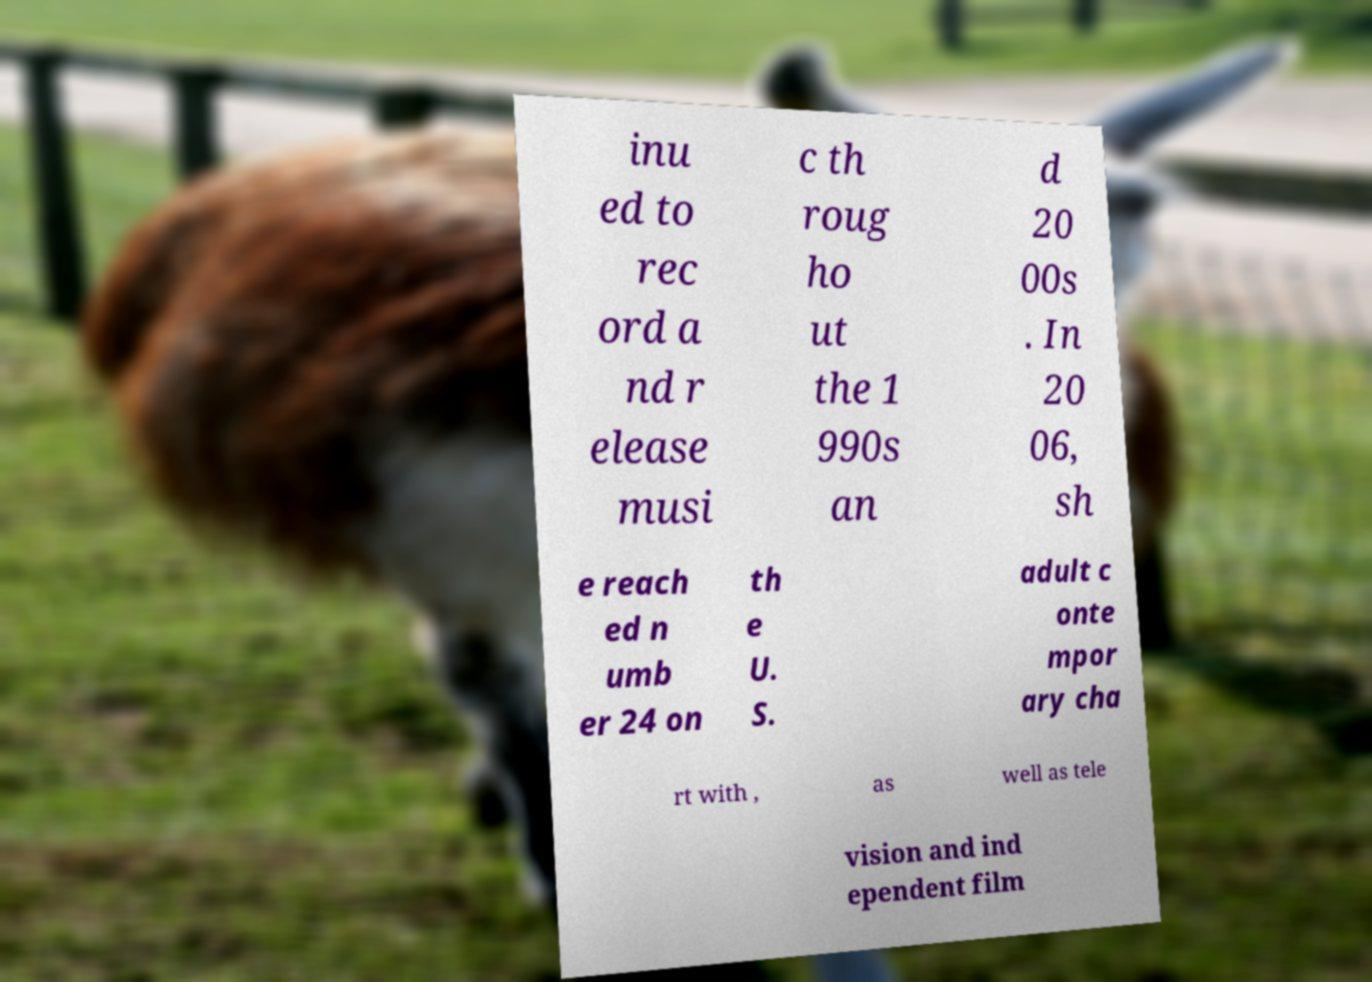Could you assist in decoding the text presented in this image and type it out clearly? inu ed to rec ord a nd r elease musi c th roug ho ut the 1 990s an d 20 00s . In 20 06, sh e reach ed n umb er 24 on th e U. S. adult c onte mpor ary cha rt with , as well as tele vision and ind ependent film 